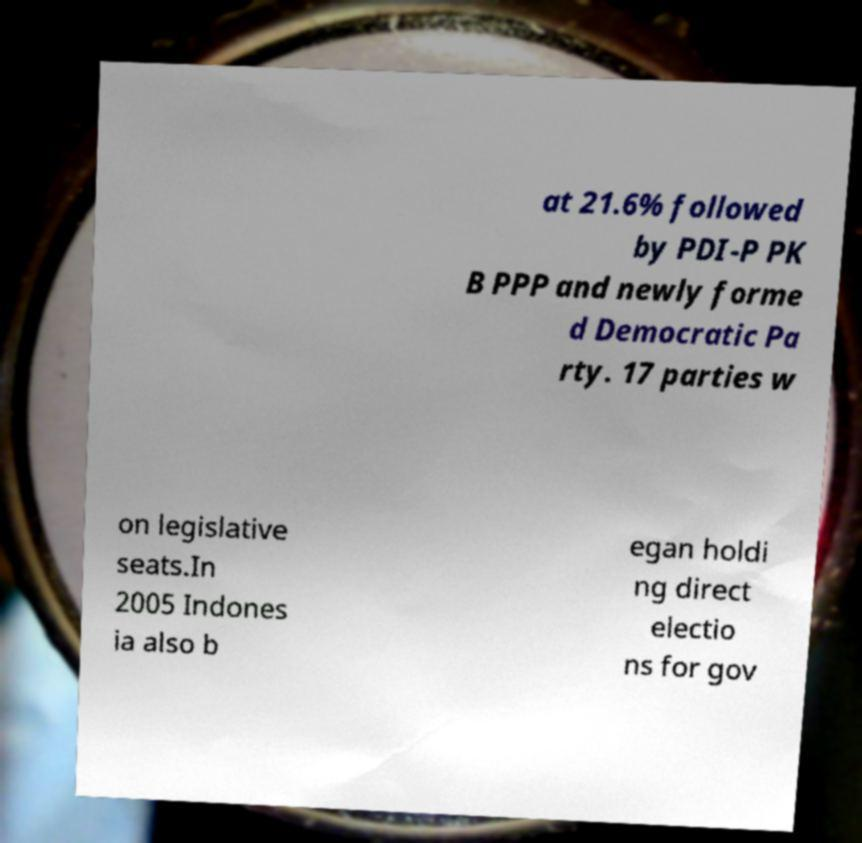Please identify and transcribe the text found in this image. at 21.6% followed by PDI-P PK B PPP and newly forme d Democratic Pa rty. 17 parties w on legislative seats.In 2005 Indones ia also b egan holdi ng direct electio ns for gov 